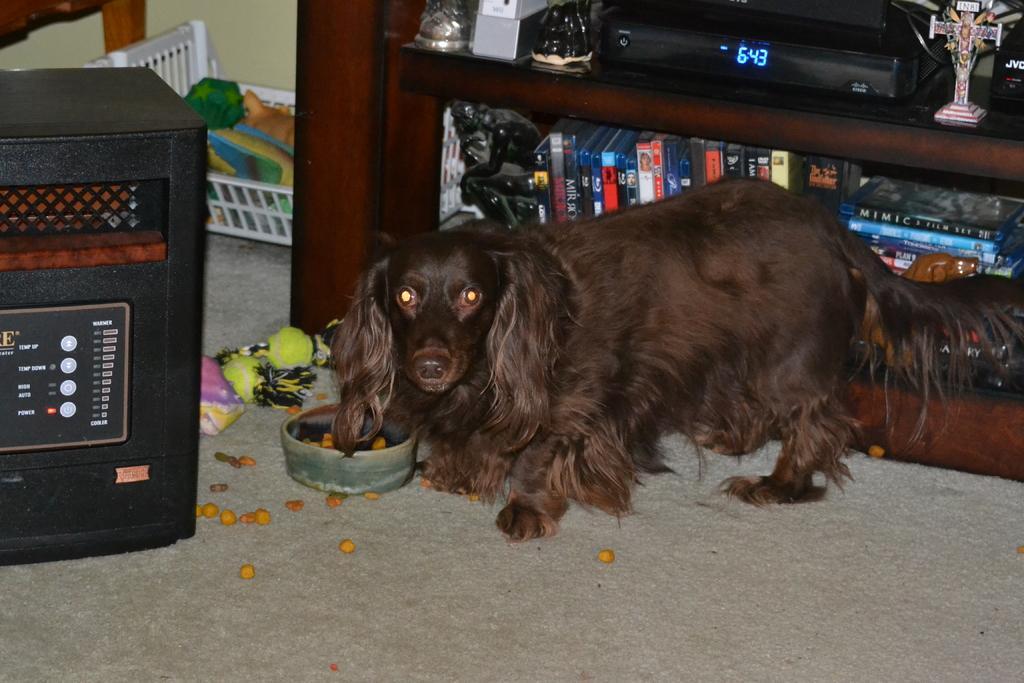Describe this image in one or two sentences. In the middle of the picture we can see a dog and food items. On the left there is a speaker. Towards right we can see shelf, in the shelf there are books, electronic gadget, sculpture and various objects. At the top left corner there is a wooden object, basket, wall and other objects. 